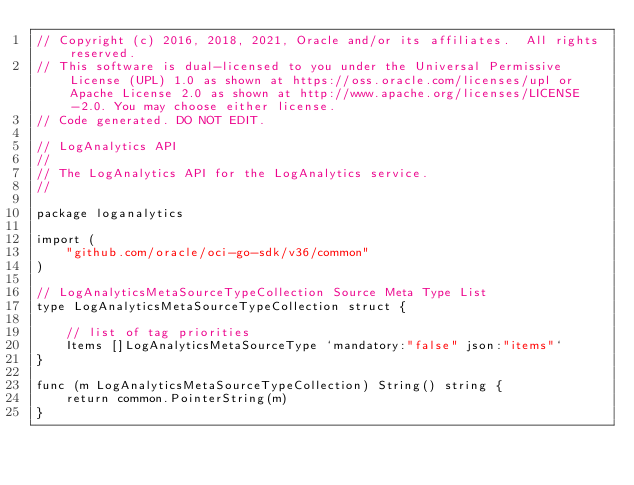<code> <loc_0><loc_0><loc_500><loc_500><_Go_>// Copyright (c) 2016, 2018, 2021, Oracle and/or its affiliates.  All rights reserved.
// This software is dual-licensed to you under the Universal Permissive License (UPL) 1.0 as shown at https://oss.oracle.com/licenses/upl or Apache License 2.0 as shown at http://www.apache.org/licenses/LICENSE-2.0. You may choose either license.
// Code generated. DO NOT EDIT.

// LogAnalytics API
//
// The LogAnalytics API for the LogAnalytics service.
//

package loganalytics

import (
	"github.com/oracle/oci-go-sdk/v36/common"
)

// LogAnalyticsMetaSourceTypeCollection Source Meta Type List
type LogAnalyticsMetaSourceTypeCollection struct {

	// list of tag priorities
	Items []LogAnalyticsMetaSourceType `mandatory:"false" json:"items"`
}

func (m LogAnalyticsMetaSourceTypeCollection) String() string {
	return common.PointerString(m)
}
</code> 